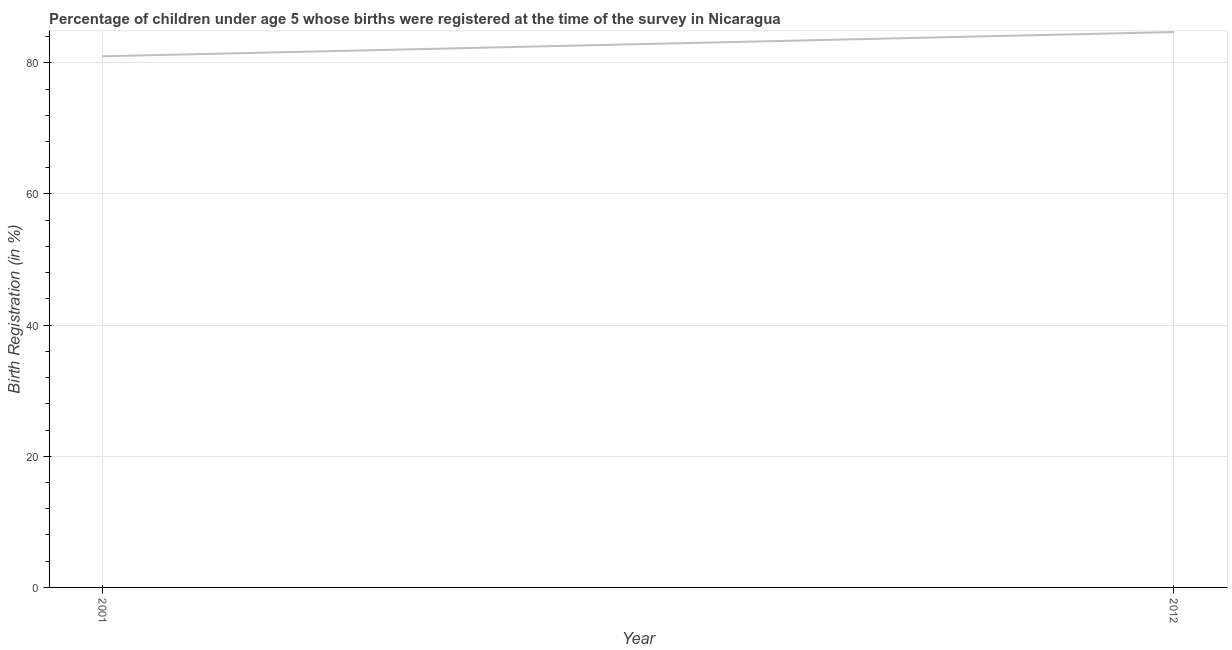What is the birth registration in 2012?
Your answer should be compact. 84.7. Across all years, what is the maximum birth registration?
Provide a succinct answer. 84.7. In which year was the birth registration minimum?
Your answer should be compact. 2001. What is the sum of the birth registration?
Your answer should be very brief. 165.7. What is the difference between the birth registration in 2001 and 2012?
Your response must be concise. -3.7. What is the average birth registration per year?
Give a very brief answer. 82.85. What is the median birth registration?
Keep it short and to the point. 82.85. What is the ratio of the birth registration in 2001 to that in 2012?
Your response must be concise. 0.96. Is the birth registration in 2001 less than that in 2012?
Provide a succinct answer. Yes. Does the birth registration monotonically increase over the years?
Your answer should be very brief. Yes. What is the difference between two consecutive major ticks on the Y-axis?
Your answer should be very brief. 20. Does the graph contain any zero values?
Your answer should be compact. No. What is the title of the graph?
Ensure brevity in your answer.  Percentage of children under age 5 whose births were registered at the time of the survey in Nicaragua. What is the label or title of the X-axis?
Ensure brevity in your answer.  Year. What is the label or title of the Y-axis?
Your response must be concise. Birth Registration (in %). What is the Birth Registration (in %) in 2001?
Give a very brief answer. 81. What is the Birth Registration (in %) of 2012?
Make the answer very short. 84.7. What is the difference between the Birth Registration (in %) in 2001 and 2012?
Your response must be concise. -3.7. What is the ratio of the Birth Registration (in %) in 2001 to that in 2012?
Give a very brief answer. 0.96. 